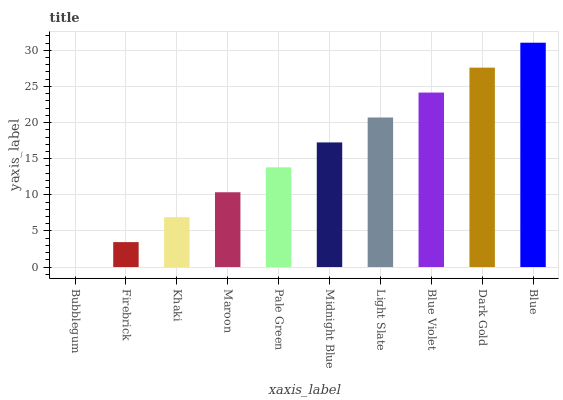Is Firebrick the minimum?
Answer yes or no. No. Is Firebrick the maximum?
Answer yes or no. No. Is Firebrick greater than Bubblegum?
Answer yes or no. Yes. Is Bubblegum less than Firebrick?
Answer yes or no. Yes. Is Bubblegum greater than Firebrick?
Answer yes or no. No. Is Firebrick less than Bubblegum?
Answer yes or no. No. Is Midnight Blue the high median?
Answer yes or no. Yes. Is Pale Green the low median?
Answer yes or no. Yes. Is Firebrick the high median?
Answer yes or no. No. Is Light Slate the low median?
Answer yes or no. No. 